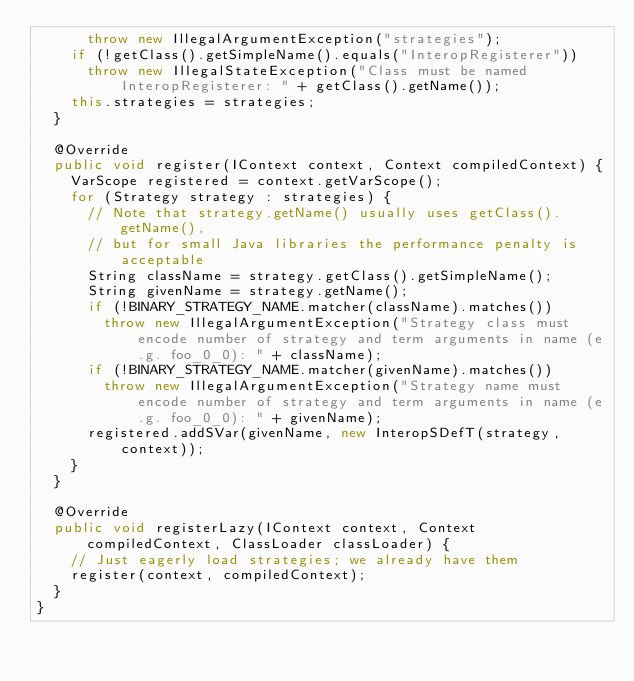Convert code to text. <code><loc_0><loc_0><loc_500><loc_500><_Java_>			throw new IllegalArgumentException("strategies");
		if (!getClass().getSimpleName().equals("InteropRegisterer"))
			throw new IllegalStateException("Class must be named InteropRegisterer: " + getClass().getName());
		this.strategies = strategies;
	}

	@Override
	public void register(IContext context, Context compiledContext) {
		VarScope registered = context.getVarScope();
		for (Strategy strategy : strategies) {
			// Note that strategy.getName() usually uses getClass().getName(),
			// but for small Java libraries the performance penalty is acceptable
			String className = strategy.getClass().getSimpleName();
			String givenName = strategy.getName();
			if (!BINARY_STRATEGY_NAME.matcher(className).matches())
				throw new IllegalArgumentException("Strategy class must encode number of strategy and term arguments in name (e.g. foo_0_0): " + className);
			if (!BINARY_STRATEGY_NAME.matcher(givenName).matches())
				throw new IllegalArgumentException("Strategy name must encode number of strategy and term arguments in name (e.g. foo_0_0): " + givenName);
			registered.addSVar(givenName, new InteropSDefT(strategy, context));
		}
	}
	
	@Override
	public void registerLazy(IContext context, Context compiledContext, ClassLoader classLoader) {
		// Just eagerly load strategies; we already have them
		register(context, compiledContext);
	}
}</code> 